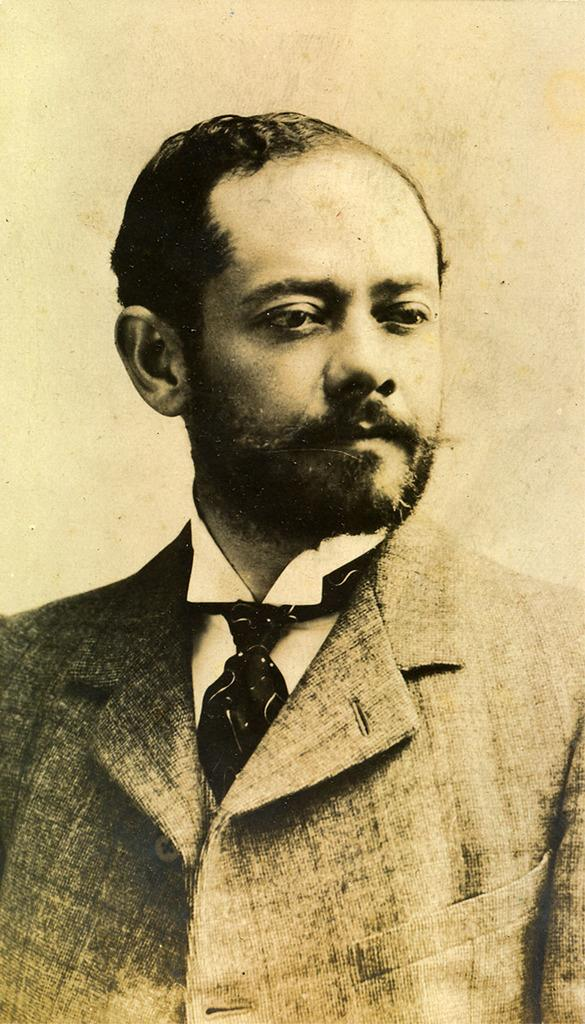Who is present in the image? There is a man in the image. What can be seen in the background of the image? There is a wall in the background of the image. How many wings does the man have in the image? The man does not have any wings in the image. What is the man doing during the wax week in the image? There is no mention of wax or week in the image, so we cannot determine what the man might be doing during a wax week. 